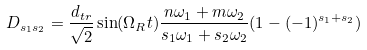<formula> <loc_0><loc_0><loc_500><loc_500>D _ { s _ { 1 } s _ { 2 } } = \frac { d _ { t r } } { \sqrt { 2 } } \sin ( \Omega _ { R } t ) \frac { n \omega _ { 1 } + m \omega _ { 2 } } { s _ { 1 } \omega _ { 1 } + s _ { 2 } \omega _ { 2 } } ( 1 - ( - 1 ) ^ { s _ { 1 } + s _ { 2 } } )</formula> 